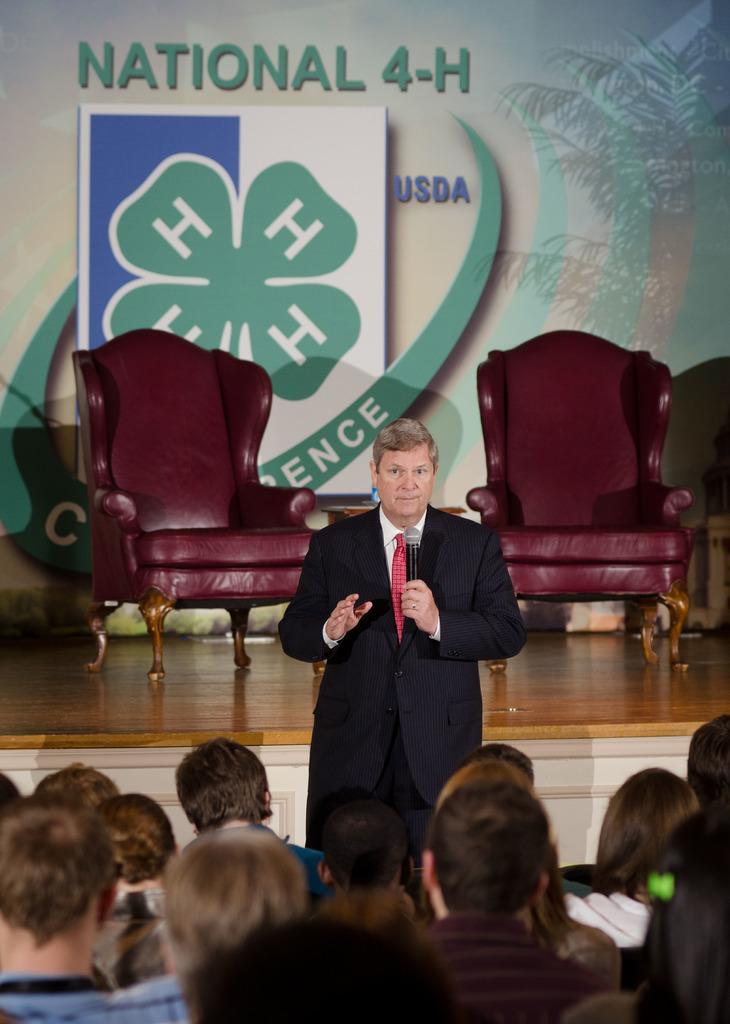Please provide a concise description of this image. A man is standing and speaking with a mic in his hand. There are group of people listening to him. 